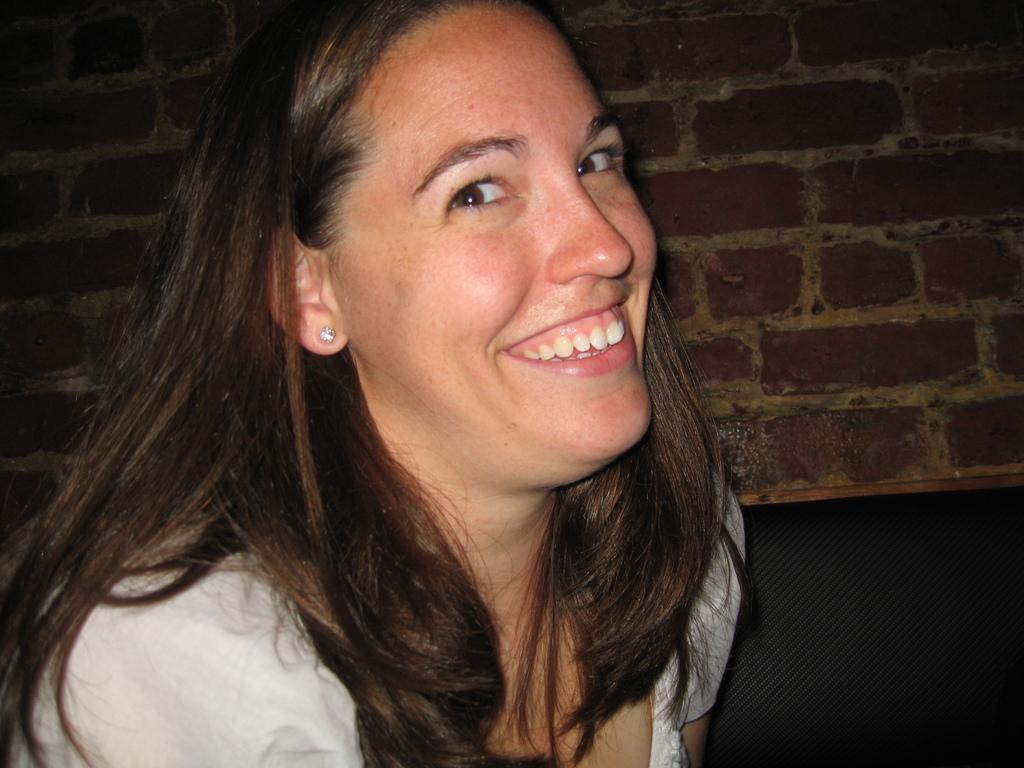Please provide a concise description of this image. In the center of the image there is a lady. In the background of the image there is a wall. 